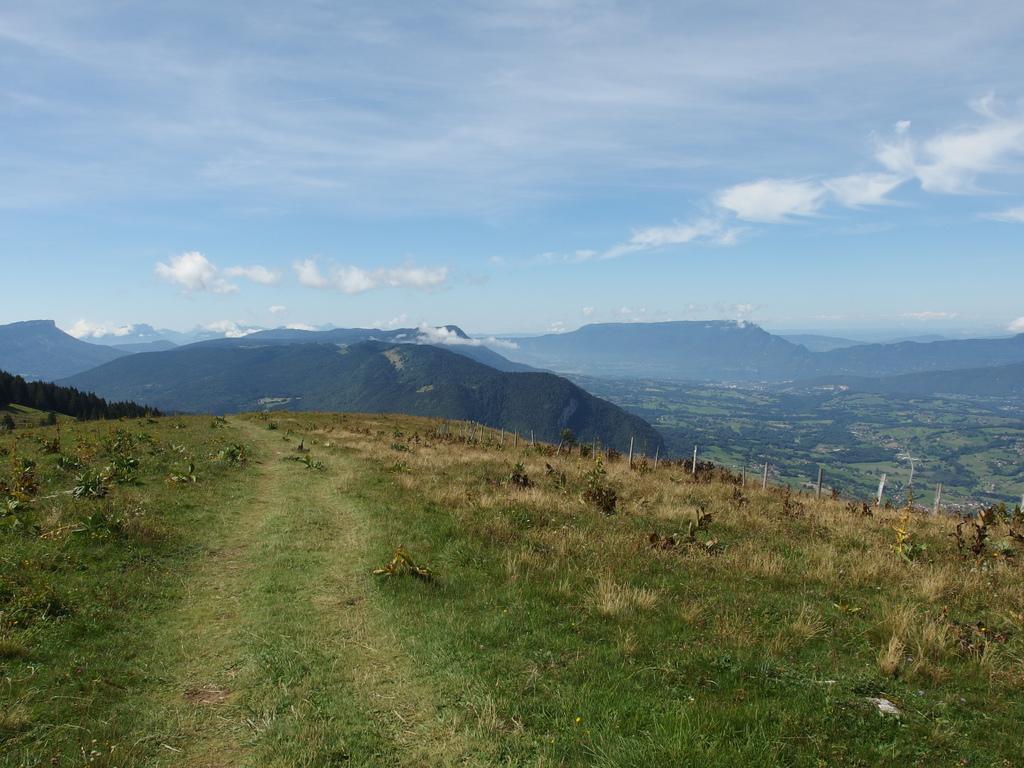In one or two sentences, can you explain what this image depicts? In this picture I can see plants, trees and I can see hills and a blue cloudy sky. I can see grass on the ground. 